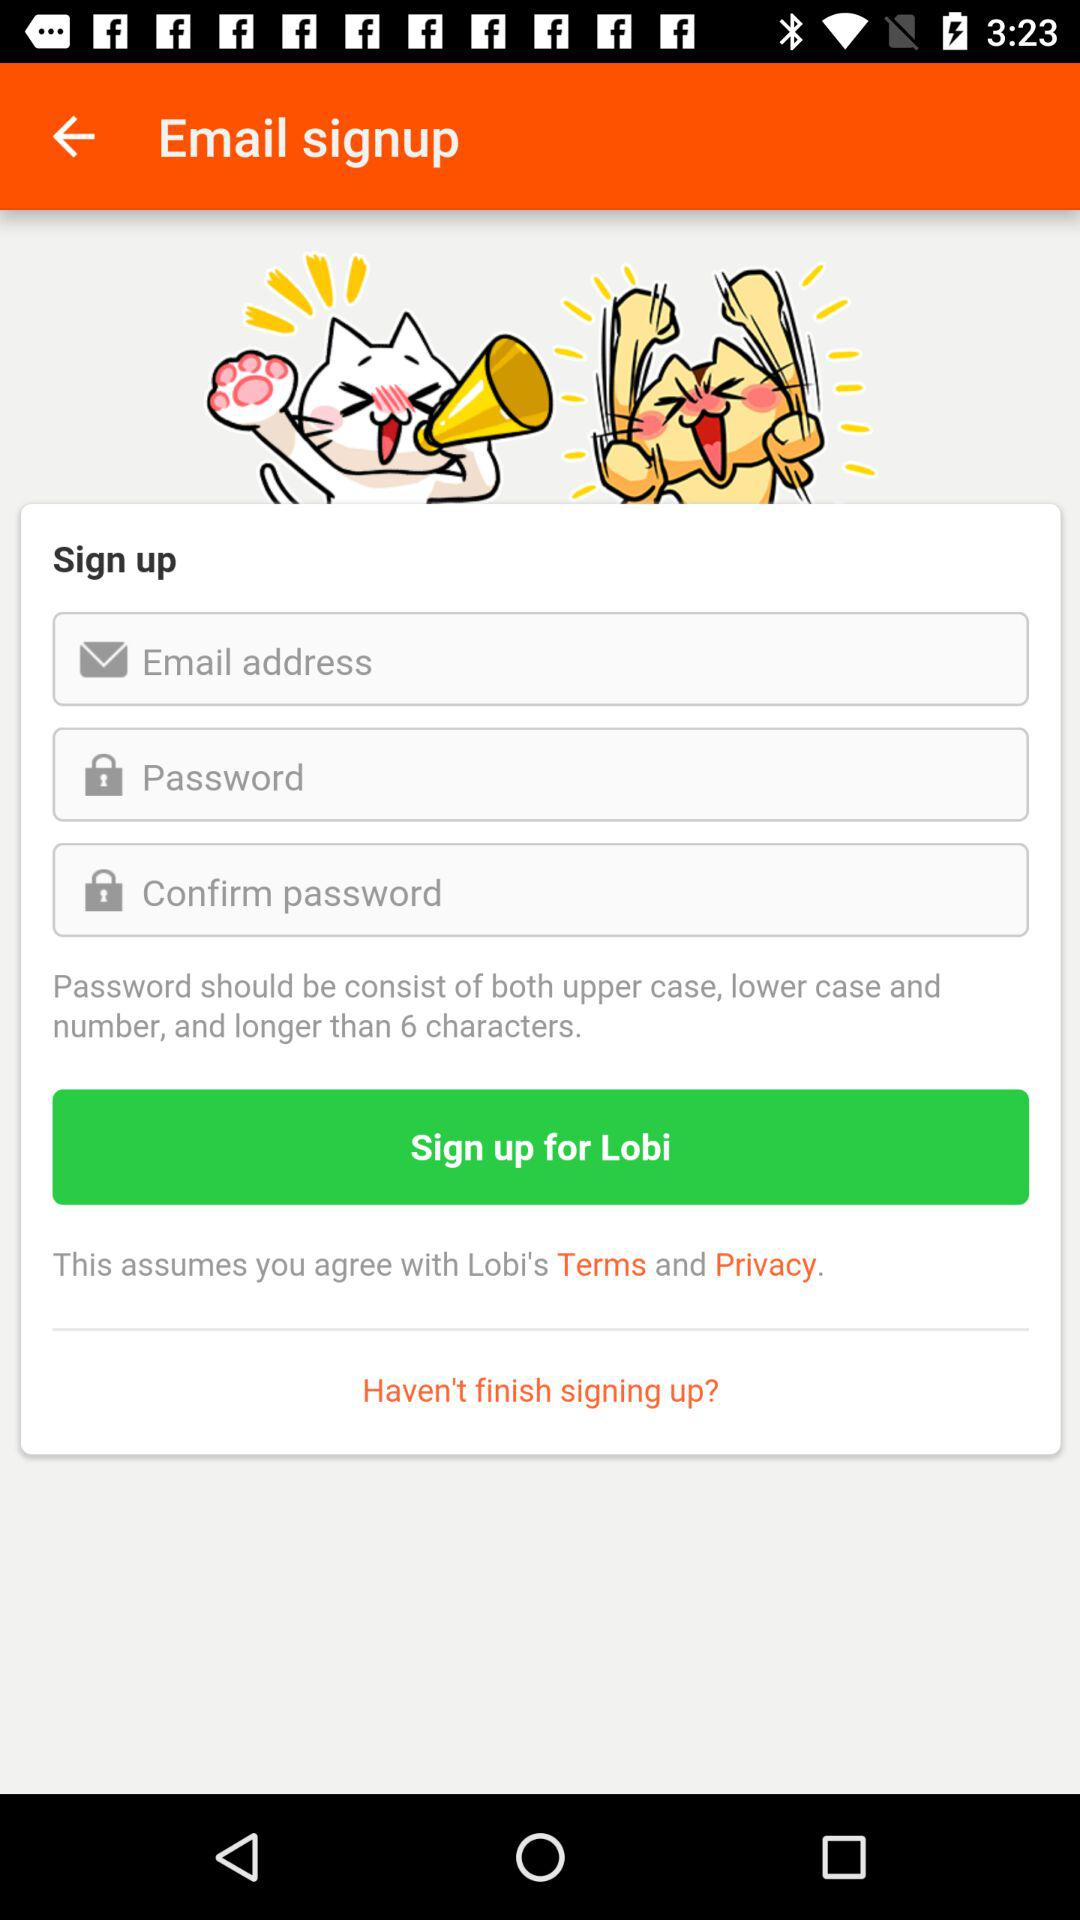What is the email address?
When the provided information is insufficient, respond with <no answer>. <no answer> 